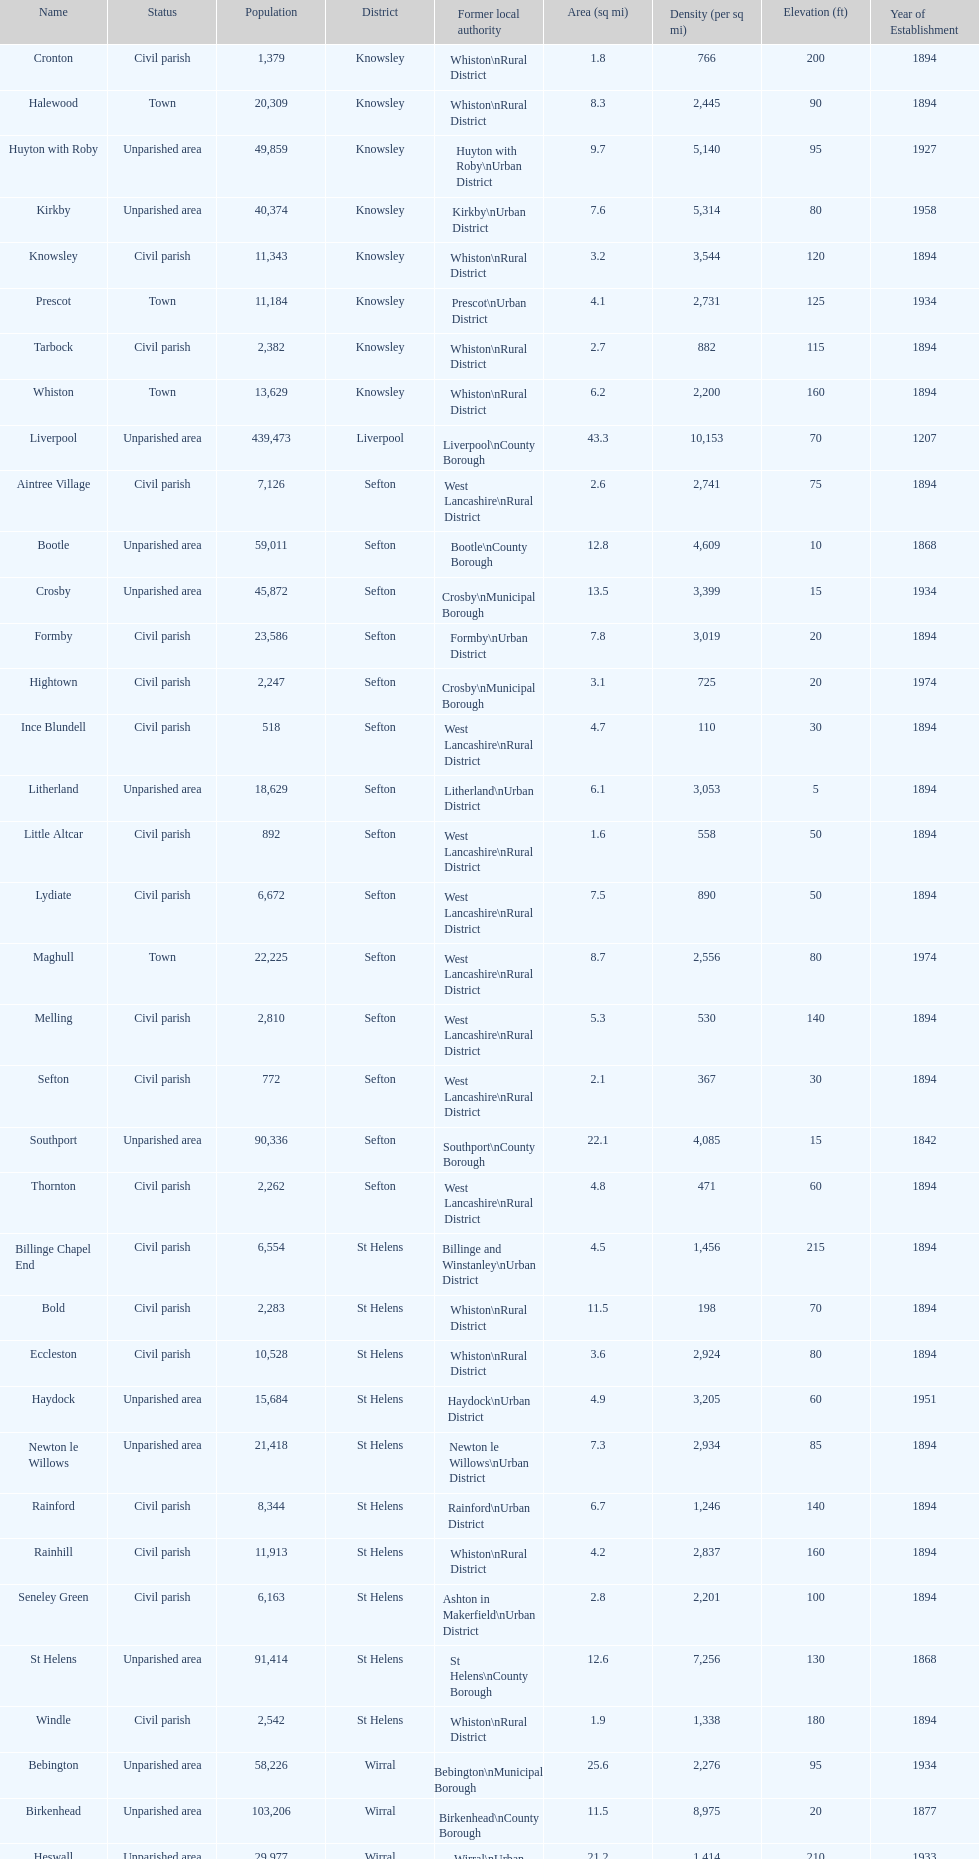How many areas are unparished areas? 15. 